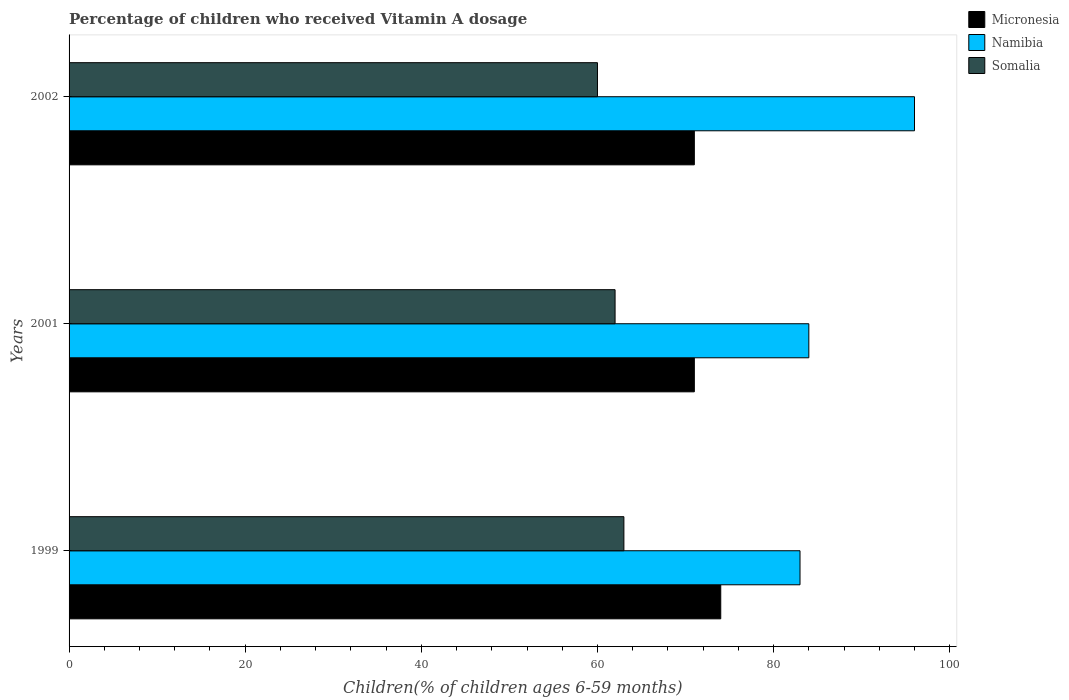How many groups of bars are there?
Your response must be concise. 3. Are the number of bars per tick equal to the number of legend labels?
Offer a terse response. Yes. How many bars are there on the 3rd tick from the bottom?
Your response must be concise. 3. In how many cases, is the number of bars for a given year not equal to the number of legend labels?
Ensure brevity in your answer.  0. What is the percentage of children who received Vitamin A dosage in Namibia in 2002?
Provide a short and direct response. 96. Across all years, what is the maximum percentage of children who received Vitamin A dosage in Namibia?
Your answer should be compact. 96. What is the total percentage of children who received Vitamin A dosage in Micronesia in the graph?
Your answer should be very brief. 216. What is the difference between the percentage of children who received Vitamin A dosage in Namibia in 1999 and that in 2001?
Make the answer very short. -1. What is the average percentage of children who received Vitamin A dosage in Namibia per year?
Give a very brief answer. 87.67. In the year 1999, what is the difference between the percentage of children who received Vitamin A dosage in Namibia and percentage of children who received Vitamin A dosage in Micronesia?
Offer a very short reply. 9. What is the ratio of the percentage of children who received Vitamin A dosage in Micronesia in 1999 to that in 2002?
Provide a short and direct response. 1.04. Is the percentage of children who received Vitamin A dosage in Namibia in 2001 less than that in 2002?
Your answer should be very brief. Yes. What is the difference between the highest and the lowest percentage of children who received Vitamin A dosage in Namibia?
Make the answer very short. 13. In how many years, is the percentage of children who received Vitamin A dosage in Namibia greater than the average percentage of children who received Vitamin A dosage in Namibia taken over all years?
Your response must be concise. 1. Is the sum of the percentage of children who received Vitamin A dosage in Namibia in 2001 and 2002 greater than the maximum percentage of children who received Vitamin A dosage in Micronesia across all years?
Give a very brief answer. Yes. What does the 2nd bar from the top in 2002 represents?
Your answer should be compact. Namibia. What does the 1st bar from the bottom in 2001 represents?
Give a very brief answer. Micronesia. How many bars are there?
Your response must be concise. 9. How many years are there in the graph?
Your response must be concise. 3. What is the difference between two consecutive major ticks on the X-axis?
Offer a very short reply. 20. Are the values on the major ticks of X-axis written in scientific E-notation?
Provide a succinct answer. No. Does the graph contain grids?
Your response must be concise. No. How many legend labels are there?
Provide a short and direct response. 3. How are the legend labels stacked?
Keep it short and to the point. Vertical. What is the title of the graph?
Provide a succinct answer. Percentage of children who received Vitamin A dosage. Does "New Caledonia" appear as one of the legend labels in the graph?
Your response must be concise. No. What is the label or title of the X-axis?
Provide a succinct answer. Children(% of children ages 6-59 months). What is the label or title of the Y-axis?
Keep it short and to the point. Years. What is the Children(% of children ages 6-59 months) in Micronesia in 1999?
Keep it short and to the point. 74. What is the Children(% of children ages 6-59 months) in Somalia in 1999?
Give a very brief answer. 63. What is the Children(% of children ages 6-59 months) in Namibia in 2001?
Provide a succinct answer. 84. What is the Children(% of children ages 6-59 months) of Namibia in 2002?
Your answer should be compact. 96. Across all years, what is the maximum Children(% of children ages 6-59 months) in Namibia?
Your answer should be compact. 96. Across all years, what is the minimum Children(% of children ages 6-59 months) of Namibia?
Your answer should be very brief. 83. Across all years, what is the minimum Children(% of children ages 6-59 months) of Somalia?
Provide a short and direct response. 60. What is the total Children(% of children ages 6-59 months) in Micronesia in the graph?
Your answer should be compact. 216. What is the total Children(% of children ages 6-59 months) in Namibia in the graph?
Your answer should be very brief. 263. What is the total Children(% of children ages 6-59 months) in Somalia in the graph?
Offer a very short reply. 185. What is the difference between the Children(% of children ages 6-59 months) in Micronesia in 1999 and that in 2001?
Keep it short and to the point. 3. What is the difference between the Children(% of children ages 6-59 months) of Namibia in 1999 and that in 2002?
Keep it short and to the point. -13. What is the difference between the Children(% of children ages 6-59 months) in Micronesia in 2001 and that in 2002?
Provide a succinct answer. 0. What is the difference between the Children(% of children ages 6-59 months) of Namibia in 2001 and that in 2002?
Your answer should be compact. -12. What is the difference between the Children(% of children ages 6-59 months) in Somalia in 2001 and that in 2002?
Give a very brief answer. 2. What is the difference between the Children(% of children ages 6-59 months) in Micronesia in 1999 and the Children(% of children ages 6-59 months) in Namibia in 2001?
Offer a terse response. -10. What is the difference between the Children(% of children ages 6-59 months) in Micronesia in 1999 and the Children(% of children ages 6-59 months) in Somalia in 2002?
Your answer should be very brief. 14. What is the difference between the Children(% of children ages 6-59 months) of Micronesia in 2001 and the Children(% of children ages 6-59 months) of Namibia in 2002?
Give a very brief answer. -25. What is the difference between the Children(% of children ages 6-59 months) of Micronesia in 2001 and the Children(% of children ages 6-59 months) of Somalia in 2002?
Offer a very short reply. 11. What is the difference between the Children(% of children ages 6-59 months) of Namibia in 2001 and the Children(% of children ages 6-59 months) of Somalia in 2002?
Your answer should be compact. 24. What is the average Children(% of children ages 6-59 months) of Micronesia per year?
Keep it short and to the point. 72. What is the average Children(% of children ages 6-59 months) in Namibia per year?
Ensure brevity in your answer.  87.67. What is the average Children(% of children ages 6-59 months) of Somalia per year?
Keep it short and to the point. 61.67. In the year 1999, what is the difference between the Children(% of children ages 6-59 months) in Micronesia and Children(% of children ages 6-59 months) in Somalia?
Your response must be concise. 11. In the year 2002, what is the difference between the Children(% of children ages 6-59 months) in Namibia and Children(% of children ages 6-59 months) in Somalia?
Give a very brief answer. 36. What is the ratio of the Children(% of children ages 6-59 months) of Micronesia in 1999 to that in 2001?
Offer a very short reply. 1.04. What is the ratio of the Children(% of children ages 6-59 months) in Namibia in 1999 to that in 2001?
Your answer should be compact. 0.99. What is the ratio of the Children(% of children ages 6-59 months) of Somalia in 1999 to that in 2001?
Provide a short and direct response. 1.02. What is the ratio of the Children(% of children ages 6-59 months) of Micronesia in 1999 to that in 2002?
Give a very brief answer. 1.04. What is the ratio of the Children(% of children ages 6-59 months) of Namibia in 1999 to that in 2002?
Your answer should be compact. 0.86. What is the ratio of the Children(% of children ages 6-59 months) of Somalia in 1999 to that in 2002?
Keep it short and to the point. 1.05. What is the ratio of the Children(% of children ages 6-59 months) of Micronesia in 2001 to that in 2002?
Provide a succinct answer. 1. What is the ratio of the Children(% of children ages 6-59 months) of Namibia in 2001 to that in 2002?
Your response must be concise. 0.88. What is the ratio of the Children(% of children ages 6-59 months) in Somalia in 2001 to that in 2002?
Your answer should be very brief. 1.03. What is the difference between the highest and the second highest Children(% of children ages 6-59 months) in Namibia?
Make the answer very short. 12. What is the difference between the highest and the second highest Children(% of children ages 6-59 months) in Somalia?
Offer a very short reply. 1. What is the difference between the highest and the lowest Children(% of children ages 6-59 months) in Namibia?
Make the answer very short. 13. 